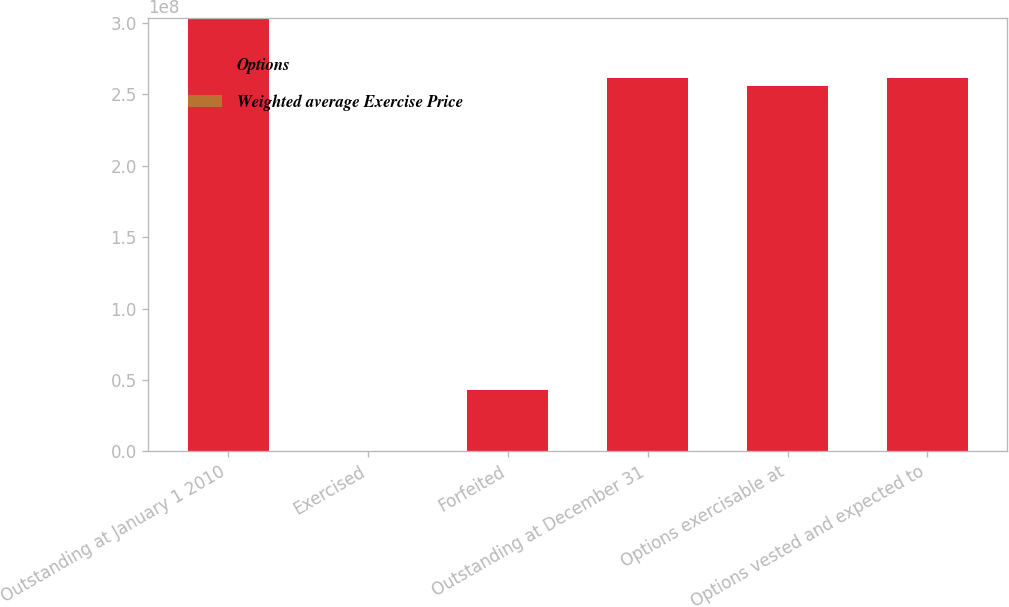Convert chart. <chart><loc_0><loc_0><loc_500><loc_500><stacked_bar_chart><ecel><fcel>Outstanding at January 1 2010<fcel>Exercised<fcel>Forfeited<fcel>Outstanding at December 31<fcel>Options exercisable at<fcel>Options vested and expected to<nl><fcel>Options<fcel>3.03723e+08<fcel>4959<fcel>4.2595e+07<fcel>2.61123e+08<fcel>2.55616e+08<fcel>2.61113e+08<nl><fcel>Weighted average Exercise Price<fcel>49.71<fcel>14.82<fcel>44.16<fcel>50.61<fcel>50.77<fcel>50.61<nl></chart> 